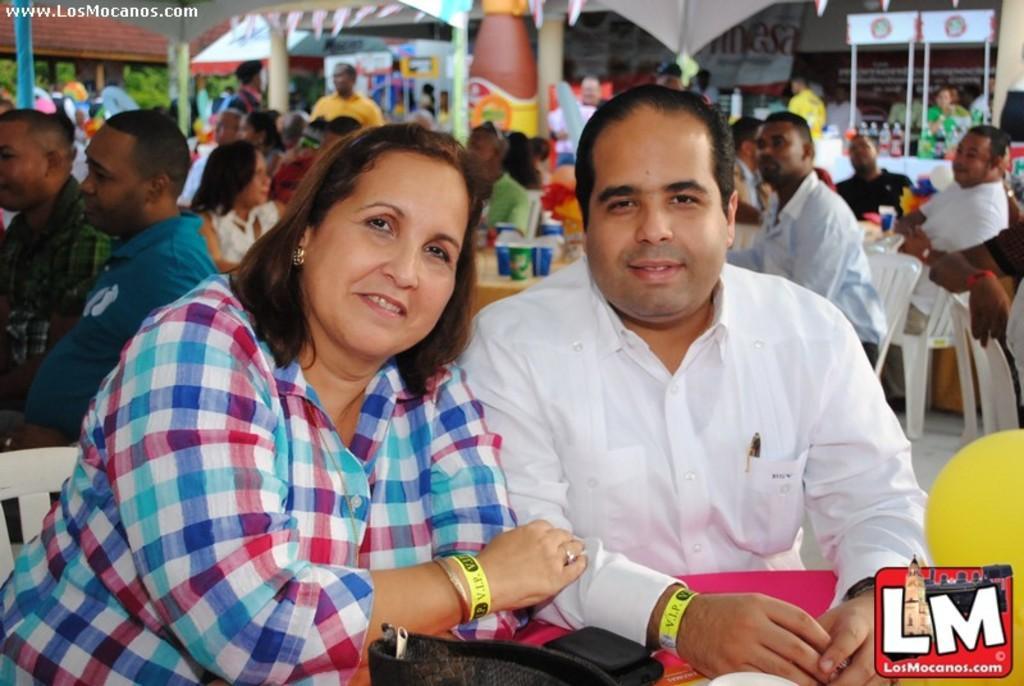Can you describe this image briefly? In this image, we can see a woman and man are sitting. They are watching and smiling. At the bottom of the image, we can see few things and logo. In the background, we can see people, chairs, tables, bottles, stall, poles, plants and few objects. On the left side top of the image, there is a watermark. 